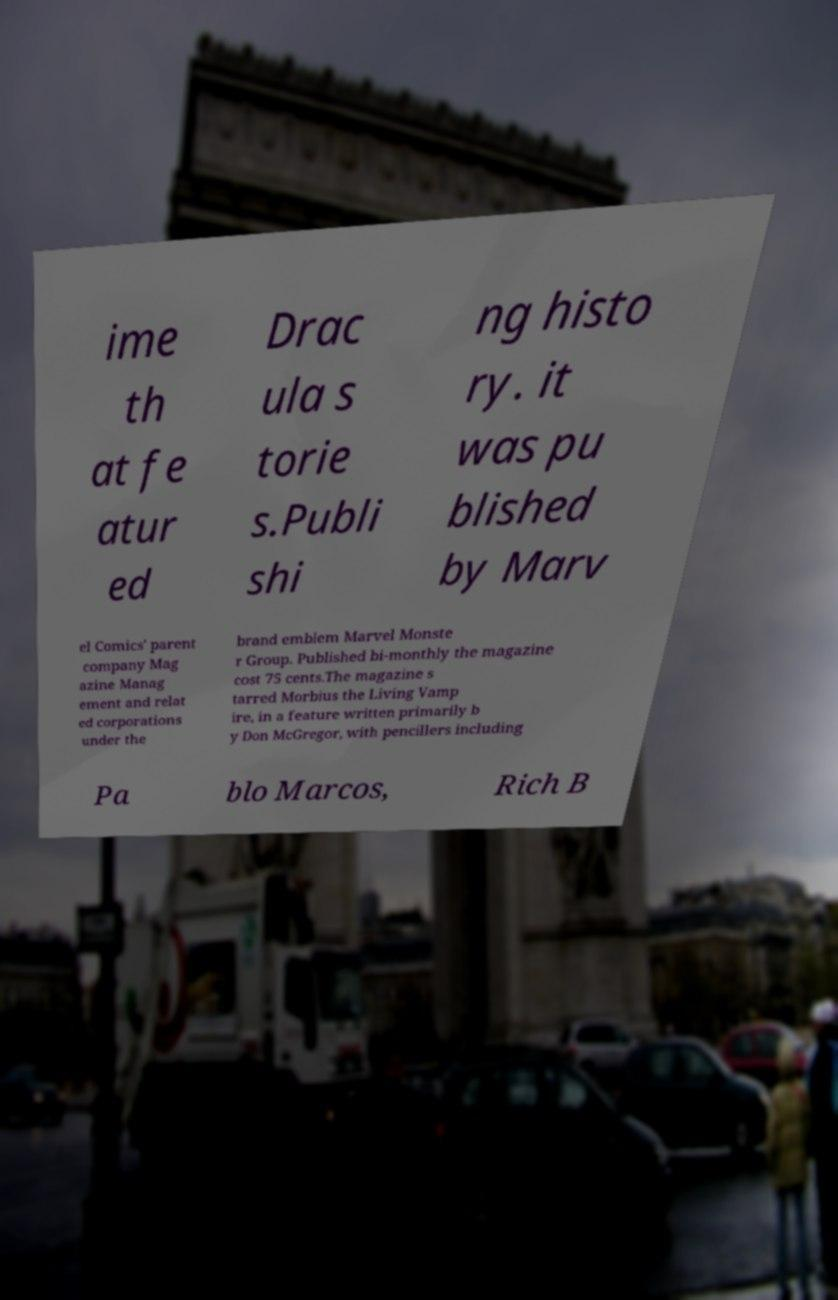Can you accurately transcribe the text from the provided image for me? ime th at fe atur ed Drac ula s torie s.Publi shi ng histo ry. it was pu blished by Marv el Comics' parent company Mag azine Manag ement and relat ed corporations under the brand emblem Marvel Monste r Group. Published bi-monthly the magazine cost 75 cents.The magazine s tarred Morbius the Living Vamp ire, in a feature written primarily b y Don McGregor, with pencillers including Pa blo Marcos, Rich B 